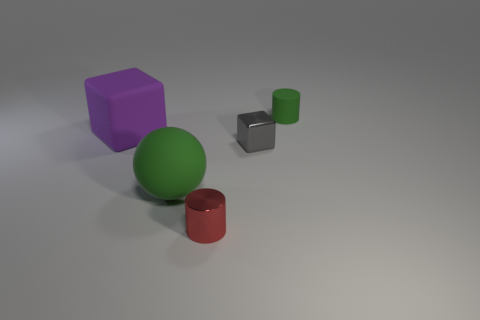Add 4 big red cubes. How many objects exist? 9 Subtract all cylinders. How many objects are left? 3 Subtract all gray cubes. How many cubes are left? 1 Subtract 1 balls. How many balls are left? 0 Subtract 0 gray cylinders. How many objects are left? 5 Subtract all yellow balls. Subtract all purple cylinders. How many balls are left? 1 Subtract all red blocks. How many green cylinders are left? 1 Subtract all small green matte cylinders. Subtract all blocks. How many objects are left? 2 Add 5 green balls. How many green balls are left? 6 Add 5 large yellow metal cubes. How many large yellow metal cubes exist? 5 